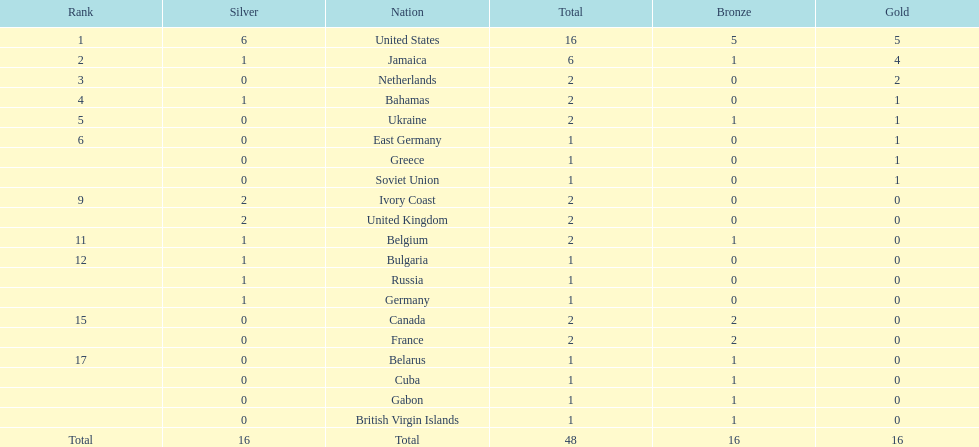What country won the most medals? United States. How many medals did the us win? 16. What is the most medals (after 16) that were won by a country? 6. Which country won 6 medals? Jamaica. 